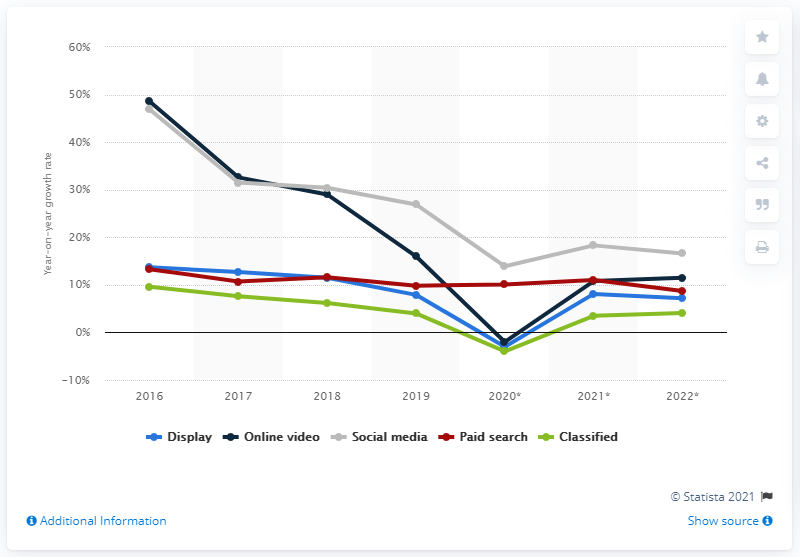Mention a couple of crucial points in this snapshot. The growth rate of social media increased in 2019. 